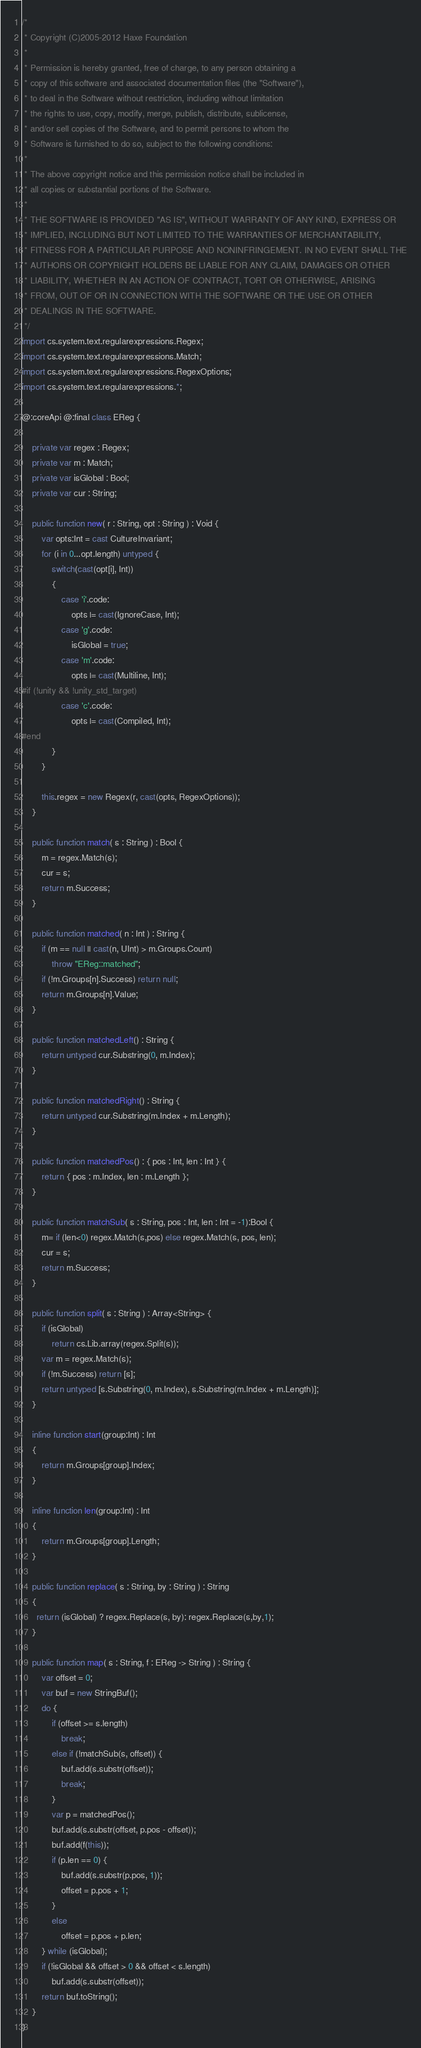Convert code to text. <code><loc_0><loc_0><loc_500><loc_500><_Haxe_>/*
 * Copyright (C)2005-2012 Haxe Foundation
 *
 * Permission is hereby granted, free of charge, to any person obtaining a
 * copy of this software and associated documentation files (the "Software"),
 * to deal in the Software without restriction, including without limitation
 * the rights to use, copy, modify, merge, publish, distribute, sublicense,
 * and/or sell copies of the Software, and to permit persons to whom the
 * Software is furnished to do so, subject to the following conditions:
 *
 * The above copyright notice and this permission notice shall be included in
 * all copies or substantial portions of the Software.
 *
 * THE SOFTWARE IS PROVIDED "AS IS", WITHOUT WARRANTY OF ANY KIND, EXPRESS OR
 * IMPLIED, INCLUDING BUT NOT LIMITED TO THE WARRANTIES OF MERCHANTABILITY,
 * FITNESS FOR A PARTICULAR PURPOSE AND NONINFRINGEMENT. IN NO EVENT SHALL THE
 * AUTHORS OR COPYRIGHT HOLDERS BE LIABLE FOR ANY CLAIM, DAMAGES OR OTHER
 * LIABILITY, WHETHER IN AN ACTION OF CONTRACT, TORT OR OTHERWISE, ARISING
 * FROM, OUT OF OR IN CONNECTION WITH THE SOFTWARE OR THE USE OR OTHER
 * DEALINGS IN THE SOFTWARE.
 */
import cs.system.text.regularexpressions.Regex;
import cs.system.text.regularexpressions.Match;
import cs.system.text.regularexpressions.RegexOptions;
import cs.system.text.regularexpressions.*;

@:coreApi @:final class EReg {

	private var regex : Regex;
	private var m : Match;
	private var isGlobal : Bool;
	private var cur : String;

	public function new( r : String, opt : String ) : Void {
		var opts:Int = cast CultureInvariant;
		for (i in 0...opt.length) untyped {
			switch(cast(opt[i], Int))
			{
				case 'i'.code:
					opts |= cast(IgnoreCase, Int);
				case 'g'.code:
					isGlobal = true;
				case 'm'.code:
					opts |= cast(Multiline, Int);
#if (!unity && !unity_std_target)
				case 'c'.code:
					opts |= cast(Compiled, Int);
#end
			}
		}

		this.regex = new Regex(r, cast(opts, RegexOptions));
	}

	public function match( s : String ) : Bool {
		m = regex.Match(s);
		cur = s;
		return m.Success;
	}

	public function matched( n : Int ) : String {
		if (m == null || cast(n, UInt) > m.Groups.Count)
			throw "EReg::matched";
		if (!m.Groups[n].Success) return null;
		return m.Groups[n].Value;
	}

	public function matchedLeft() : String {
		return untyped cur.Substring(0, m.Index);
	}

	public function matchedRight() : String {
		return untyped cur.Substring(m.Index + m.Length);
	}

	public function matchedPos() : { pos : Int, len : Int } {
		return { pos : m.Index, len : m.Length };
	}

	public function matchSub( s : String, pos : Int, len : Int = -1):Bool {
		m= if (len<0) regex.Match(s,pos) else regex.Match(s, pos, len);
		cur = s;
		return m.Success;
	}

	public function split( s : String ) : Array<String> {
		if (isGlobal)
			return cs.Lib.array(regex.Split(s));
		var m = regex.Match(s);
		if (!m.Success) return [s];
		return untyped [s.Substring(0, m.Index), s.Substring(m.Index + m.Length)];
	}

	inline function start(group:Int) : Int
	{
		return m.Groups[group].Index;
	}

	inline function len(group:Int) : Int
	{
		return m.Groups[group].Length;
	}

	public function replace( s : String, by : String ) : String
	{
      return (isGlobal) ? regex.Replace(s, by): regex.Replace(s,by,1);
	}

	public function map( s : String, f : EReg -> String ) : String {
		var offset = 0;
		var buf = new StringBuf();
		do {
			if (offset >= s.length)
				break;
			else if (!matchSub(s, offset)) {
				buf.add(s.substr(offset));
				break;
			}
			var p = matchedPos();
			buf.add(s.substr(offset, p.pos - offset));
			buf.add(f(this));
			if (p.len == 0) {
				buf.add(s.substr(p.pos, 1));
				offset = p.pos + 1;
			}
			else
				offset = p.pos + p.len;
		} while (isGlobal);
		if (!isGlobal && offset > 0 && offset < s.length)
			buf.add(s.substr(offset));
		return buf.toString();
	}
}
</code> 